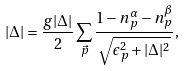<formula> <loc_0><loc_0><loc_500><loc_500>| \Delta | = \frac { g | \Delta | } { 2 } \sum _ { \vec { p } } \frac { 1 - n _ { p } ^ { \alpha } - n _ { p } ^ { \beta } } { \sqrt { \epsilon _ { p } ^ { 2 } + | \Delta | ^ { 2 } } } ,</formula> 